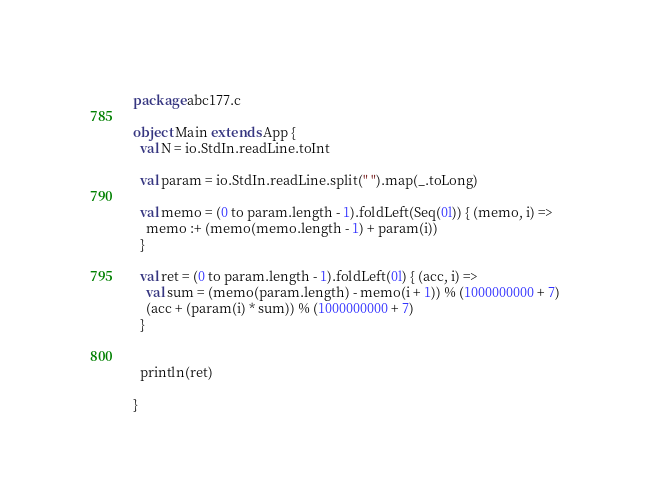Convert code to text. <code><loc_0><loc_0><loc_500><loc_500><_Scala_>package abc177.c

object Main extends App {
  val N = io.StdIn.readLine.toInt

  val param = io.StdIn.readLine.split(" ").map(_.toLong)

  val memo = (0 to param.length - 1).foldLeft(Seq(0l)) { (memo, i) => 
    memo :+ (memo(memo.length - 1) + param(i))
  }

  val ret = (0 to param.length - 1).foldLeft(0l) { (acc, i) =>
    val sum = (memo(param.length) - memo(i + 1)) % (1000000000 + 7)
    (acc + (param(i) * sum)) % (1000000000 + 7)
  }


  println(ret)

}

</code> 